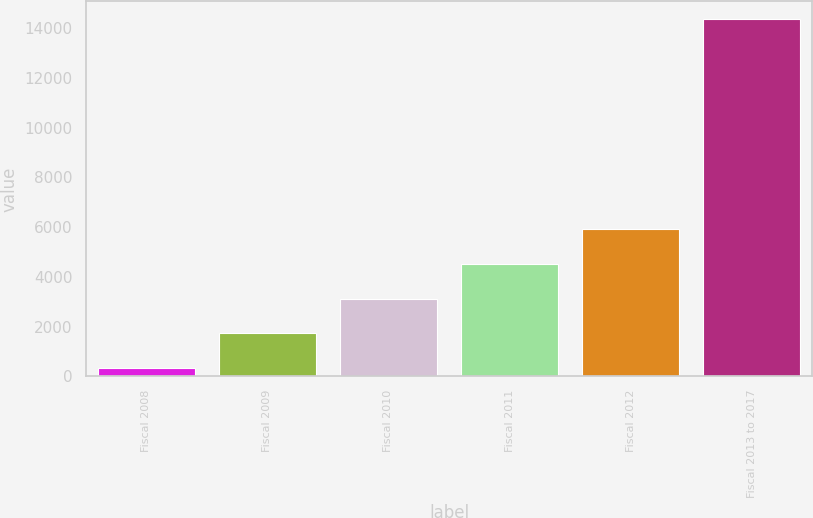<chart> <loc_0><loc_0><loc_500><loc_500><bar_chart><fcel>Fiscal 2008<fcel>Fiscal 2009<fcel>Fiscal 2010<fcel>Fiscal 2011<fcel>Fiscal 2012<fcel>Fiscal 2013 to 2017<nl><fcel>326<fcel>1729.3<fcel>3132.6<fcel>4535.9<fcel>5939.2<fcel>14359<nl></chart> 